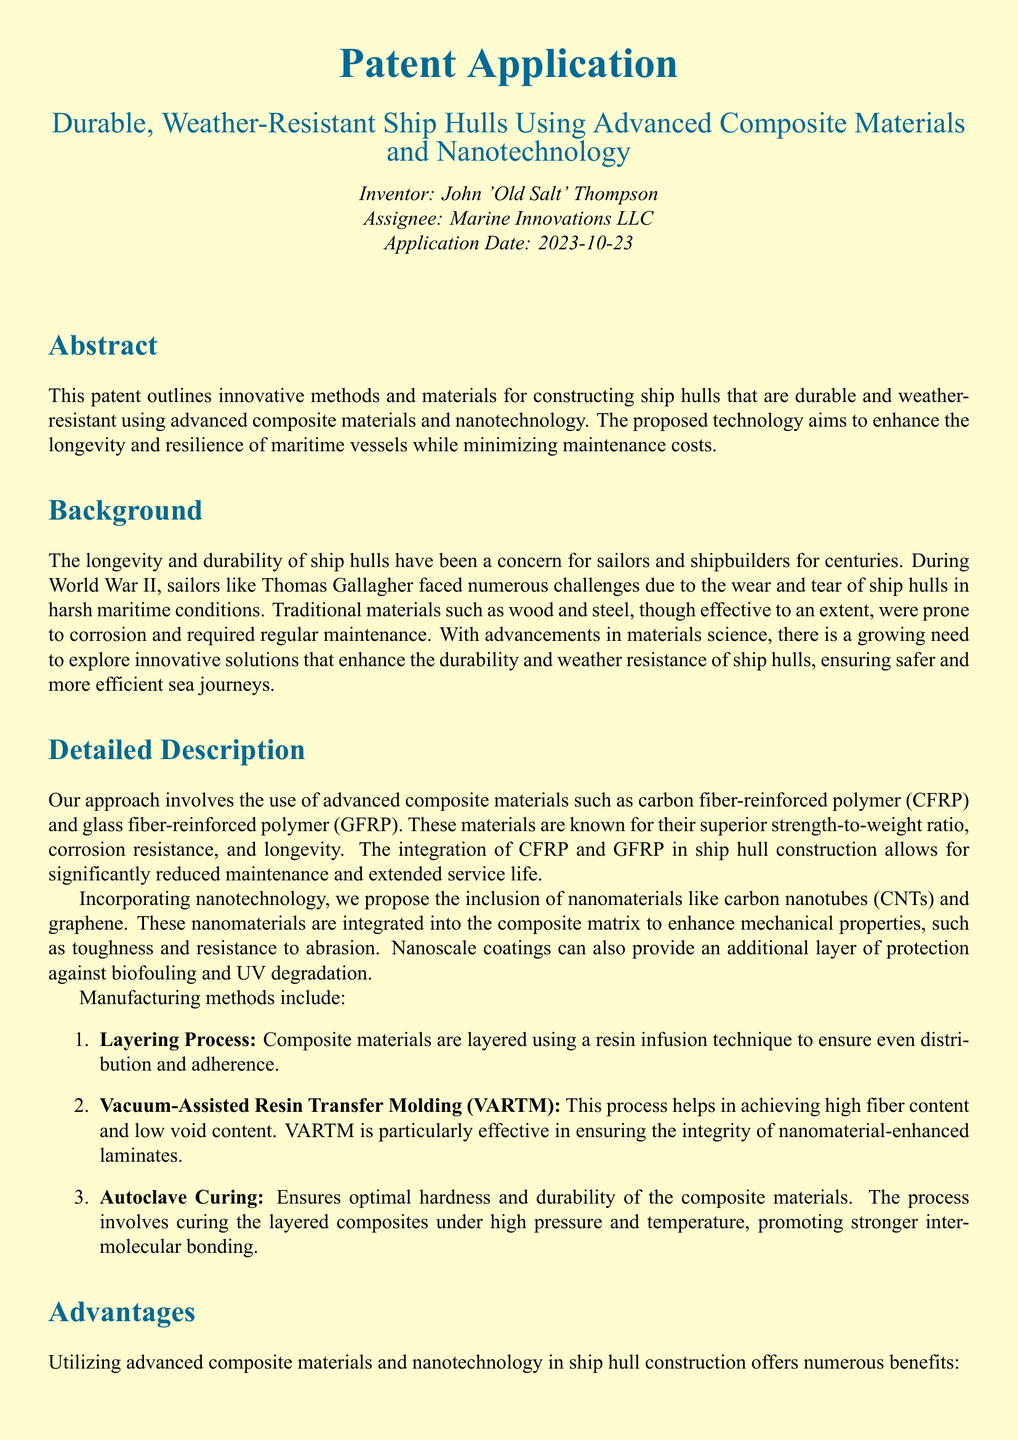What is the title of the patent application? The title is stated at the top of the document and is "Durable, Weather-Resistant Ship Hulls Using Advanced Composite Materials and Nanotechnology."
Answer: Durable, Weather-Resistant Ship Hulls Using Advanced Composite Materials and Nanotechnology Who is the inventor of the patent? The inventor's name is indicated near the top of the document.
Answer: John 'Old Salt' Thompson When was the patent application filed? The application date is mentioned in the introduction of the document.
Answer: 2023-10-23 What advanced composite materials are mentioned in the detailed description? The relevant section lists the materials used for ship hull construction.
Answer: carbon fiber-reinforced polymer (CFRP) and glass fiber-reinforced polymer (GFRP) What process is used to achieve high fiber content and low void content? The document explains various manufacturing methods, including one specific process.
Answer: Vacuum-Assisted Resin Transfer Molding (VARTM) List one advantage of using advanced composite materials in ship hull construction. The advantage section provides multiple benefits, and one is highlighted.
Answer: Enhanced durability What is one of the claims made in this patent application? Claims are listed towards the end, providing specific assertions of the patent.
Answer: A method for constructing a ship hull using carbon fiber-reinforced polymer (CFRP) and glass fiber-reinforced polymer (GFRP) to enhance durability and weather resistance What nanomaterials are proposed for inclusion in the composite matrix? The detailed description mentions specific nanomaterials that are integrated into the composites.
Answer: carbon nanotubes (CNTs) and graphene What technique is used for curing the layered composites? The document details processes involved in manufacturing the ship hulls, including a method mentioned.
Answer: Autoclave Curing 